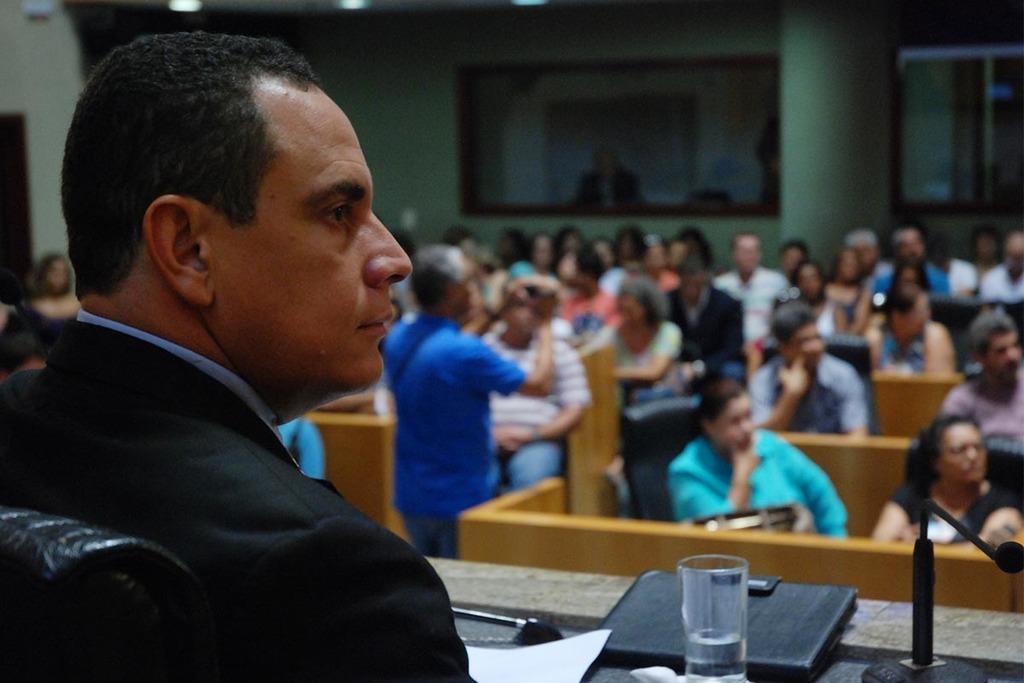In one or two sentences, can you explain what this image depicts? In the left a man is sitting in the chair there is a water glass on this table Before him there are people sitting on the chair and looking at the right side there are lights at the top. 